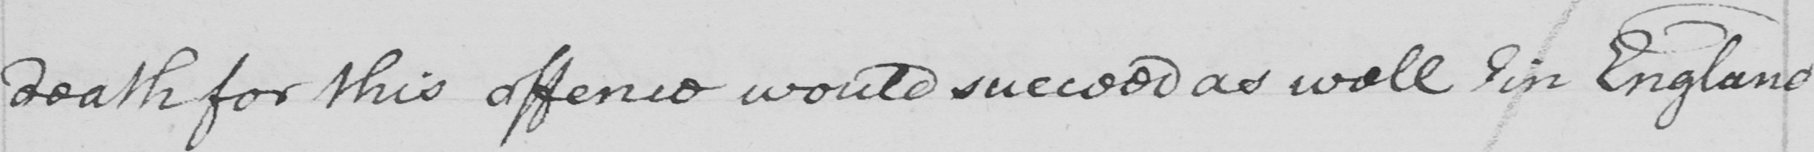Please transcribe the handwritten text in this image. death for this offence would succeed as well in England 